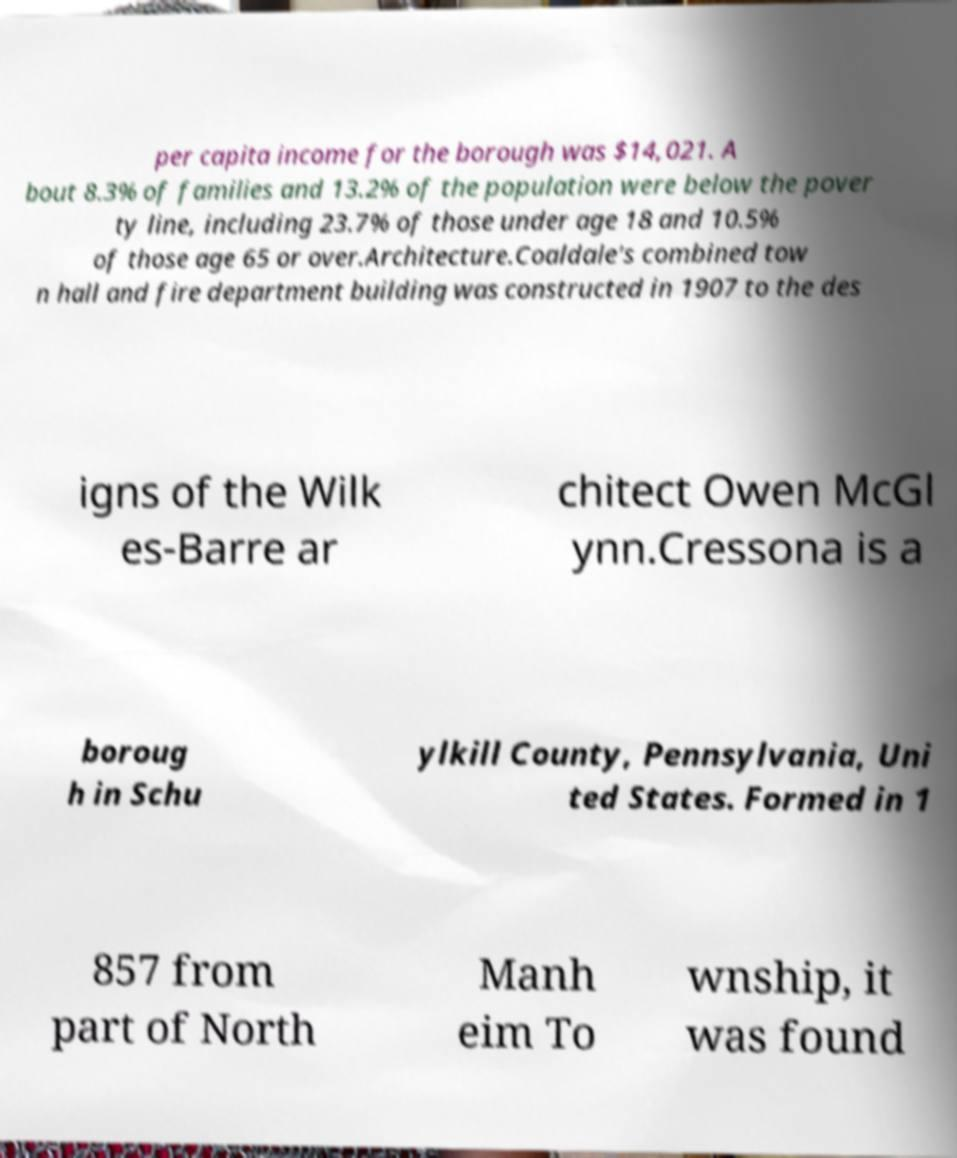For documentation purposes, I need the text within this image transcribed. Could you provide that? per capita income for the borough was $14,021. A bout 8.3% of families and 13.2% of the population were below the pover ty line, including 23.7% of those under age 18 and 10.5% of those age 65 or over.Architecture.Coaldale's combined tow n hall and fire department building was constructed in 1907 to the des igns of the Wilk es-Barre ar chitect Owen McGl ynn.Cressona is a boroug h in Schu ylkill County, Pennsylvania, Uni ted States. Formed in 1 857 from part of North Manh eim To wnship, it was found 